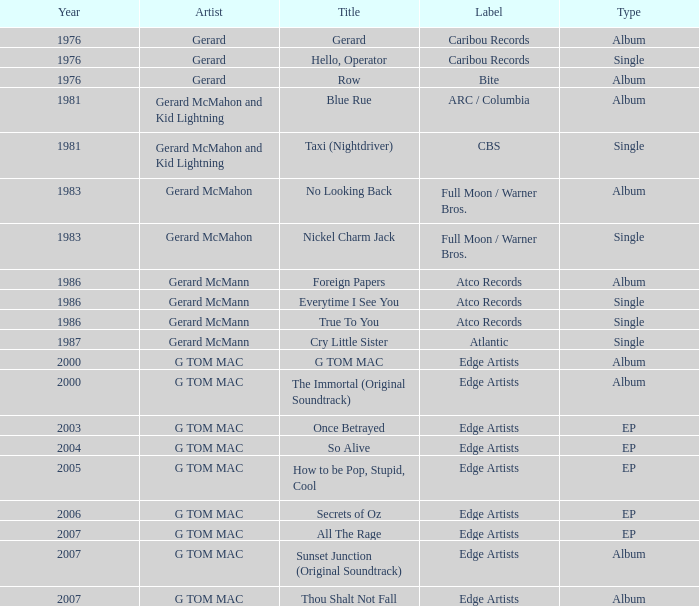Which type has a title of so alive? EP. Parse the table in full. {'header': ['Year', 'Artist', 'Title', 'Label', 'Type'], 'rows': [['1976', 'Gerard', 'Gerard', 'Caribou Records', 'Album'], ['1976', 'Gerard', 'Hello, Operator', 'Caribou Records', 'Single'], ['1976', 'Gerard', 'Row', 'Bite', 'Album'], ['1981', 'Gerard McMahon and Kid Lightning', 'Blue Rue', 'ARC / Columbia', 'Album'], ['1981', 'Gerard McMahon and Kid Lightning', 'Taxi (Nightdriver)', 'CBS', 'Single'], ['1983', 'Gerard McMahon', 'No Looking Back', 'Full Moon / Warner Bros.', 'Album'], ['1983', 'Gerard McMahon', 'Nickel Charm Jack', 'Full Moon / Warner Bros.', 'Single'], ['1986', 'Gerard McMann', 'Foreign Papers', 'Atco Records', 'Album'], ['1986', 'Gerard McMann', 'Everytime I See You', 'Atco Records', 'Single'], ['1986', 'Gerard McMann', 'True To You', 'Atco Records', 'Single'], ['1987', 'Gerard McMann', 'Cry Little Sister', 'Atlantic', 'Single'], ['2000', 'G TOM MAC', 'G TOM MAC', 'Edge Artists', 'Album'], ['2000', 'G TOM MAC', 'The Immortal (Original Soundtrack)', 'Edge Artists', 'Album'], ['2003', 'G TOM MAC', 'Once Betrayed', 'Edge Artists', 'EP'], ['2004', 'G TOM MAC', 'So Alive', 'Edge Artists', 'EP'], ['2005', 'G TOM MAC', 'How to be Pop, Stupid, Cool', 'Edge Artists', 'EP'], ['2006', 'G TOM MAC', 'Secrets of Oz', 'Edge Artists', 'EP'], ['2007', 'G TOM MAC', 'All The Rage', 'Edge Artists', 'EP'], ['2007', 'G TOM MAC', 'Sunset Junction (Original Soundtrack)', 'Edge Artists', 'Album'], ['2007', 'G TOM MAC', 'Thou Shalt Not Fall', 'Edge Artists', 'Album']]} 